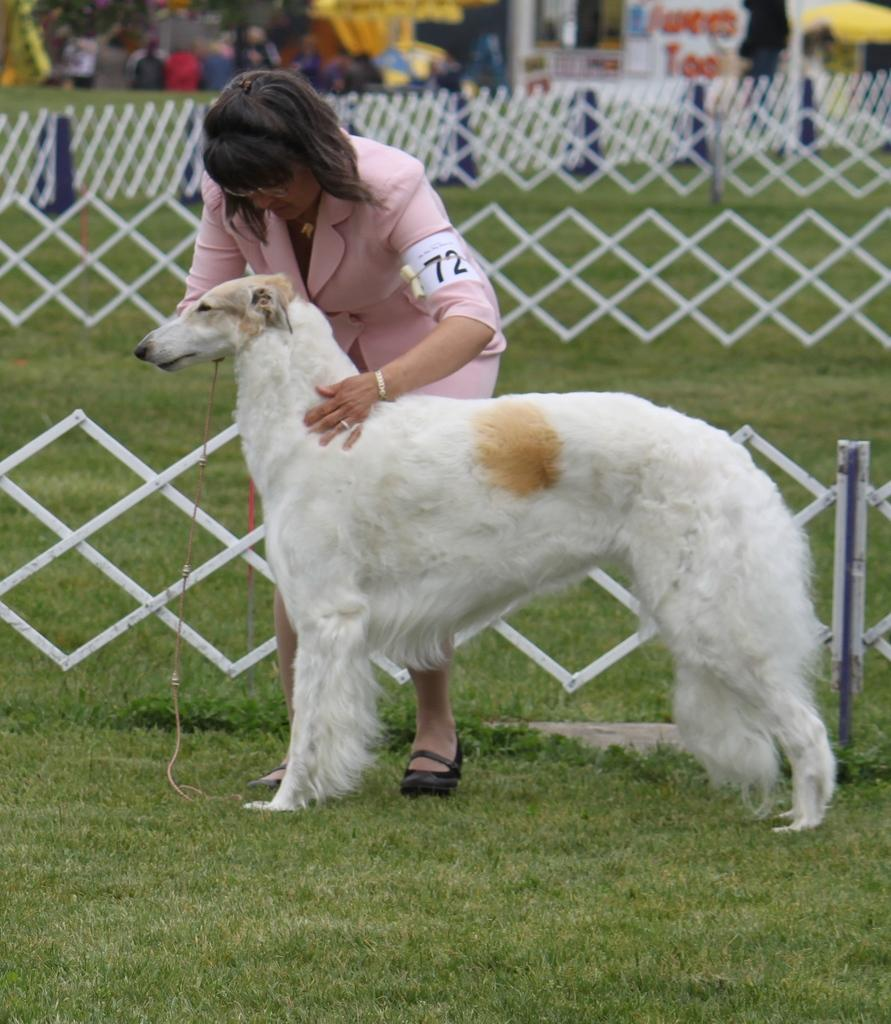Who is the main subject in the image? There is a lady in the image. What is the lady doing in the image? The lady is catching a white dog in the image. Where does the scene take place? The scene is set in a farm. What can be seen in the background of the farm? In the background, there are many toys and kids playing. What type of fencing is present in the farm? There is white fencing in the farm. Is there a river flowing through the farm in the image? No, there is no river visible in the image. How many babies can be seen playing with the toys in the background? There is no baby present in the image; only kids are playing in the background. 